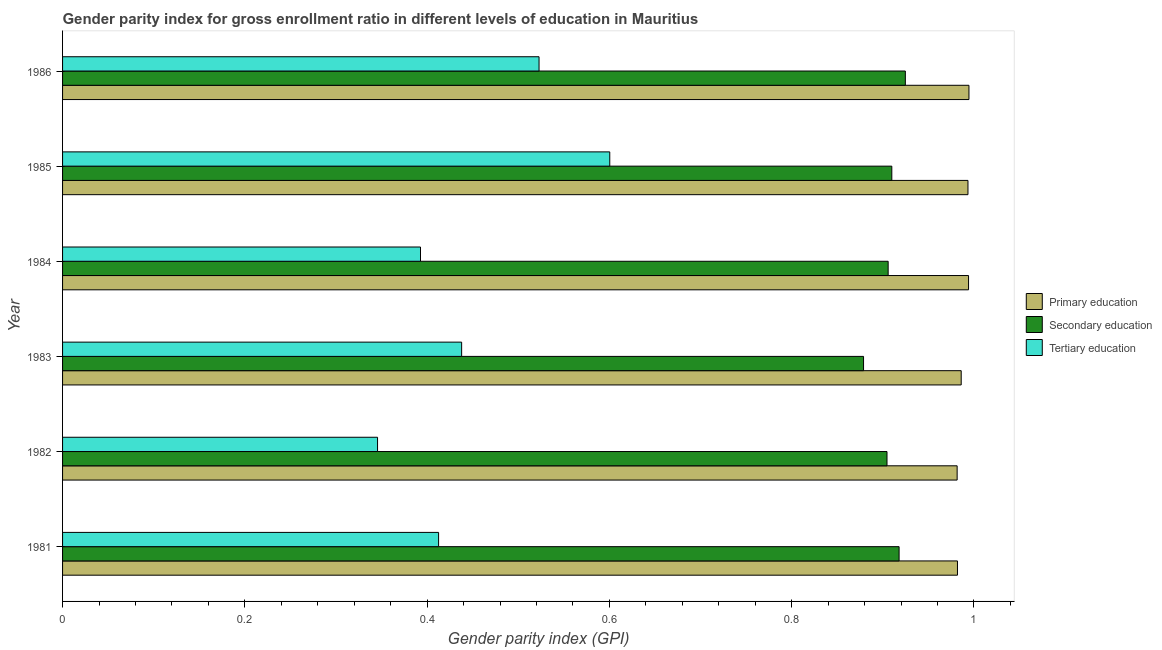How many different coloured bars are there?
Offer a very short reply. 3. How many groups of bars are there?
Offer a very short reply. 6. Are the number of bars on each tick of the Y-axis equal?
Give a very brief answer. Yes. What is the label of the 3rd group of bars from the top?
Your answer should be very brief. 1984. What is the gender parity index in primary education in 1985?
Ensure brevity in your answer.  0.99. Across all years, what is the maximum gender parity index in tertiary education?
Your answer should be very brief. 0.6. Across all years, what is the minimum gender parity index in tertiary education?
Your answer should be compact. 0.35. In which year was the gender parity index in secondary education maximum?
Give a very brief answer. 1986. In which year was the gender parity index in secondary education minimum?
Provide a short and direct response. 1983. What is the total gender parity index in tertiary education in the graph?
Provide a succinct answer. 2.71. What is the difference between the gender parity index in primary education in 1982 and that in 1984?
Make the answer very short. -0.01. What is the difference between the gender parity index in primary education in 1981 and the gender parity index in secondary education in 1982?
Keep it short and to the point. 0.08. In the year 1984, what is the difference between the gender parity index in primary education and gender parity index in tertiary education?
Your response must be concise. 0.6. In how many years, is the gender parity index in tertiary education greater than 0.6000000000000001 ?
Ensure brevity in your answer.  1. What is the ratio of the gender parity index in tertiary education in 1982 to that in 1985?
Make the answer very short. 0.58. Is the gender parity index in primary education in 1983 less than that in 1984?
Your response must be concise. Yes. What is the difference between the highest and the second highest gender parity index in secondary education?
Provide a succinct answer. 0.01. In how many years, is the gender parity index in secondary education greater than the average gender parity index in secondary education taken over all years?
Provide a short and direct response. 3. Is the sum of the gender parity index in primary education in 1981 and 1986 greater than the maximum gender parity index in tertiary education across all years?
Provide a short and direct response. Yes. What does the 1st bar from the top in 1985 represents?
Your answer should be compact. Tertiary education. Is it the case that in every year, the sum of the gender parity index in primary education and gender parity index in secondary education is greater than the gender parity index in tertiary education?
Provide a succinct answer. Yes. Does the graph contain grids?
Offer a very short reply. No. Where does the legend appear in the graph?
Your answer should be compact. Center right. What is the title of the graph?
Offer a very short reply. Gender parity index for gross enrollment ratio in different levels of education in Mauritius. Does "Transport services" appear as one of the legend labels in the graph?
Your answer should be compact. No. What is the label or title of the X-axis?
Keep it short and to the point. Gender parity index (GPI). What is the label or title of the Y-axis?
Provide a short and direct response. Year. What is the Gender parity index (GPI) in Primary education in 1981?
Keep it short and to the point. 0.98. What is the Gender parity index (GPI) of Secondary education in 1981?
Offer a terse response. 0.92. What is the Gender parity index (GPI) of Tertiary education in 1981?
Give a very brief answer. 0.41. What is the Gender parity index (GPI) of Primary education in 1982?
Make the answer very short. 0.98. What is the Gender parity index (GPI) in Secondary education in 1982?
Ensure brevity in your answer.  0.9. What is the Gender parity index (GPI) of Tertiary education in 1982?
Offer a very short reply. 0.35. What is the Gender parity index (GPI) in Primary education in 1983?
Your answer should be very brief. 0.99. What is the Gender parity index (GPI) of Secondary education in 1983?
Your answer should be very brief. 0.88. What is the Gender parity index (GPI) in Tertiary education in 1983?
Provide a succinct answer. 0.44. What is the Gender parity index (GPI) of Primary education in 1984?
Offer a very short reply. 0.99. What is the Gender parity index (GPI) of Secondary education in 1984?
Give a very brief answer. 0.91. What is the Gender parity index (GPI) in Tertiary education in 1984?
Keep it short and to the point. 0.39. What is the Gender parity index (GPI) of Primary education in 1985?
Give a very brief answer. 0.99. What is the Gender parity index (GPI) of Secondary education in 1985?
Provide a short and direct response. 0.91. What is the Gender parity index (GPI) of Tertiary education in 1985?
Offer a very short reply. 0.6. What is the Gender parity index (GPI) in Primary education in 1986?
Your answer should be very brief. 0.99. What is the Gender parity index (GPI) in Secondary education in 1986?
Make the answer very short. 0.92. What is the Gender parity index (GPI) of Tertiary education in 1986?
Your answer should be very brief. 0.52. Across all years, what is the maximum Gender parity index (GPI) of Primary education?
Your response must be concise. 0.99. Across all years, what is the maximum Gender parity index (GPI) of Secondary education?
Ensure brevity in your answer.  0.92. Across all years, what is the maximum Gender parity index (GPI) in Tertiary education?
Give a very brief answer. 0.6. Across all years, what is the minimum Gender parity index (GPI) of Primary education?
Offer a very short reply. 0.98. Across all years, what is the minimum Gender parity index (GPI) in Secondary education?
Provide a short and direct response. 0.88. Across all years, what is the minimum Gender parity index (GPI) in Tertiary education?
Keep it short and to the point. 0.35. What is the total Gender parity index (GPI) in Primary education in the graph?
Provide a short and direct response. 5.93. What is the total Gender parity index (GPI) in Secondary education in the graph?
Your answer should be compact. 5.44. What is the total Gender parity index (GPI) in Tertiary education in the graph?
Give a very brief answer. 2.71. What is the difference between the Gender parity index (GPI) in Primary education in 1981 and that in 1982?
Make the answer very short. 0. What is the difference between the Gender parity index (GPI) in Secondary education in 1981 and that in 1982?
Ensure brevity in your answer.  0.01. What is the difference between the Gender parity index (GPI) of Tertiary education in 1981 and that in 1982?
Offer a very short reply. 0.07. What is the difference between the Gender parity index (GPI) in Primary education in 1981 and that in 1983?
Your response must be concise. -0. What is the difference between the Gender parity index (GPI) of Secondary education in 1981 and that in 1983?
Provide a succinct answer. 0.04. What is the difference between the Gender parity index (GPI) in Tertiary education in 1981 and that in 1983?
Give a very brief answer. -0.03. What is the difference between the Gender parity index (GPI) in Primary education in 1981 and that in 1984?
Your answer should be compact. -0.01. What is the difference between the Gender parity index (GPI) of Secondary education in 1981 and that in 1984?
Your answer should be very brief. 0.01. What is the difference between the Gender parity index (GPI) in Tertiary education in 1981 and that in 1984?
Offer a very short reply. 0.02. What is the difference between the Gender parity index (GPI) of Primary education in 1981 and that in 1985?
Provide a short and direct response. -0.01. What is the difference between the Gender parity index (GPI) of Secondary education in 1981 and that in 1985?
Offer a terse response. 0.01. What is the difference between the Gender parity index (GPI) of Tertiary education in 1981 and that in 1985?
Provide a succinct answer. -0.19. What is the difference between the Gender parity index (GPI) in Primary education in 1981 and that in 1986?
Offer a very short reply. -0.01. What is the difference between the Gender parity index (GPI) of Secondary education in 1981 and that in 1986?
Your answer should be very brief. -0.01. What is the difference between the Gender parity index (GPI) in Tertiary education in 1981 and that in 1986?
Ensure brevity in your answer.  -0.11. What is the difference between the Gender parity index (GPI) of Primary education in 1982 and that in 1983?
Your answer should be very brief. -0. What is the difference between the Gender parity index (GPI) of Secondary education in 1982 and that in 1983?
Keep it short and to the point. 0.03. What is the difference between the Gender parity index (GPI) of Tertiary education in 1982 and that in 1983?
Your response must be concise. -0.09. What is the difference between the Gender parity index (GPI) of Primary education in 1982 and that in 1984?
Provide a succinct answer. -0.01. What is the difference between the Gender parity index (GPI) of Secondary education in 1982 and that in 1984?
Offer a terse response. -0. What is the difference between the Gender parity index (GPI) in Tertiary education in 1982 and that in 1984?
Your response must be concise. -0.05. What is the difference between the Gender parity index (GPI) of Primary education in 1982 and that in 1985?
Make the answer very short. -0.01. What is the difference between the Gender parity index (GPI) of Secondary education in 1982 and that in 1985?
Offer a terse response. -0.01. What is the difference between the Gender parity index (GPI) in Tertiary education in 1982 and that in 1985?
Your answer should be very brief. -0.25. What is the difference between the Gender parity index (GPI) in Primary education in 1982 and that in 1986?
Offer a terse response. -0.01. What is the difference between the Gender parity index (GPI) in Secondary education in 1982 and that in 1986?
Keep it short and to the point. -0.02. What is the difference between the Gender parity index (GPI) of Tertiary education in 1982 and that in 1986?
Provide a short and direct response. -0.18. What is the difference between the Gender parity index (GPI) in Primary education in 1983 and that in 1984?
Provide a short and direct response. -0.01. What is the difference between the Gender parity index (GPI) of Secondary education in 1983 and that in 1984?
Ensure brevity in your answer.  -0.03. What is the difference between the Gender parity index (GPI) of Tertiary education in 1983 and that in 1984?
Ensure brevity in your answer.  0.05. What is the difference between the Gender parity index (GPI) of Primary education in 1983 and that in 1985?
Give a very brief answer. -0.01. What is the difference between the Gender parity index (GPI) in Secondary education in 1983 and that in 1985?
Offer a very short reply. -0.03. What is the difference between the Gender parity index (GPI) in Tertiary education in 1983 and that in 1985?
Your answer should be compact. -0.16. What is the difference between the Gender parity index (GPI) of Primary education in 1983 and that in 1986?
Ensure brevity in your answer.  -0.01. What is the difference between the Gender parity index (GPI) of Secondary education in 1983 and that in 1986?
Provide a succinct answer. -0.05. What is the difference between the Gender parity index (GPI) of Tertiary education in 1983 and that in 1986?
Offer a very short reply. -0.08. What is the difference between the Gender parity index (GPI) in Primary education in 1984 and that in 1985?
Offer a terse response. 0. What is the difference between the Gender parity index (GPI) of Secondary education in 1984 and that in 1985?
Make the answer very short. -0. What is the difference between the Gender parity index (GPI) in Tertiary education in 1984 and that in 1985?
Offer a terse response. -0.21. What is the difference between the Gender parity index (GPI) of Primary education in 1984 and that in 1986?
Your answer should be very brief. -0. What is the difference between the Gender parity index (GPI) in Secondary education in 1984 and that in 1986?
Offer a terse response. -0.02. What is the difference between the Gender parity index (GPI) in Tertiary education in 1984 and that in 1986?
Your answer should be very brief. -0.13. What is the difference between the Gender parity index (GPI) of Primary education in 1985 and that in 1986?
Your answer should be very brief. -0. What is the difference between the Gender parity index (GPI) of Secondary education in 1985 and that in 1986?
Give a very brief answer. -0.01. What is the difference between the Gender parity index (GPI) in Tertiary education in 1985 and that in 1986?
Provide a succinct answer. 0.08. What is the difference between the Gender parity index (GPI) of Primary education in 1981 and the Gender parity index (GPI) of Secondary education in 1982?
Offer a very short reply. 0.08. What is the difference between the Gender parity index (GPI) of Primary education in 1981 and the Gender parity index (GPI) of Tertiary education in 1982?
Ensure brevity in your answer.  0.64. What is the difference between the Gender parity index (GPI) in Secondary education in 1981 and the Gender parity index (GPI) in Tertiary education in 1982?
Offer a very short reply. 0.57. What is the difference between the Gender parity index (GPI) in Primary education in 1981 and the Gender parity index (GPI) in Secondary education in 1983?
Your answer should be very brief. 0.1. What is the difference between the Gender parity index (GPI) in Primary education in 1981 and the Gender parity index (GPI) in Tertiary education in 1983?
Provide a succinct answer. 0.54. What is the difference between the Gender parity index (GPI) of Secondary education in 1981 and the Gender parity index (GPI) of Tertiary education in 1983?
Keep it short and to the point. 0.48. What is the difference between the Gender parity index (GPI) of Primary education in 1981 and the Gender parity index (GPI) of Secondary education in 1984?
Your answer should be very brief. 0.08. What is the difference between the Gender parity index (GPI) in Primary education in 1981 and the Gender parity index (GPI) in Tertiary education in 1984?
Offer a very short reply. 0.59. What is the difference between the Gender parity index (GPI) of Secondary education in 1981 and the Gender parity index (GPI) of Tertiary education in 1984?
Your answer should be very brief. 0.53. What is the difference between the Gender parity index (GPI) of Primary education in 1981 and the Gender parity index (GPI) of Secondary education in 1985?
Give a very brief answer. 0.07. What is the difference between the Gender parity index (GPI) in Primary education in 1981 and the Gender parity index (GPI) in Tertiary education in 1985?
Keep it short and to the point. 0.38. What is the difference between the Gender parity index (GPI) of Secondary education in 1981 and the Gender parity index (GPI) of Tertiary education in 1985?
Your answer should be very brief. 0.32. What is the difference between the Gender parity index (GPI) of Primary education in 1981 and the Gender parity index (GPI) of Secondary education in 1986?
Provide a succinct answer. 0.06. What is the difference between the Gender parity index (GPI) of Primary education in 1981 and the Gender parity index (GPI) of Tertiary education in 1986?
Your answer should be very brief. 0.46. What is the difference between the Gender parity index (GPI) in Secondary education in 1981 and the Gender parity index (GPI) in Tertiary education in 1986?
Provide a short and direct response. 0.4. What is the difference between the Gender parity index (GPI) in Primary education in 1982 and the Gender parity index (GPI) in Secondary education in 1983?
Offer a terse response. 0.1. What is the difference between the Gender parity index (GPI) of Primary education in 1982 and the Gender parity index (GPI) of Tertiary education in 1983?
Give a very brief answer. 0.54. What is the difference between the Gender parity index (GPI) in Secondary education in 1982 and the Gender parity index (GPI) in Tertiary education in 1983?
Ensure brevity in your answer.  0.47. What is the difference between the Gender parity index (GPI) of Primary education in 1982 and the Gender parity index (GPI) of Secondary education in 1984?
Provide a short and direct response. 0.08. What is the difference between the Gender parity index (GPI) of Primary education in 1982 and the Gender parity index (GPI) of Tertiary education in 1984?
Give a very brief answer. 0.59. What is the difference between the Gender parity index (GPI) of Secondary education in 1982 and the Gender parity index (GPI) of Tertiary education in 1984?
Provide a short and direct response. 0.51. What is the difference between the Gender parity index (GPI) of Primary education in 1982 and the Gender parity index (GPI) of Secondary education in 1985?
Your answer should be compact. 0.07. What is the difference between the Gender parity index (GPI) in Primary education in 1982 and the Gender parity index (GPI) in Tertiary education in 1985?
Your answer should be compact. 0.38. What is the difference between the Gender parity index (GPI) in Secondary education in 1982 and the Gender parity index (GPI) in Tertiary education in 1985?
Your response must be concise. 0.3. What is the difference between the Gender parity index (GPI) in Primary education in 1982 and the Gender parity index (GPI) in Secondary education in 1986?
Offer a very short reply. 0.06. What is the difference between the Gender parity index (GPI) of Primary education in 1982 and the Gender parity index (GPI) of Tertiary education in 1986?
Give a very brief answer. 0.46. What is the difference between the Gender parity index (GPI) in Secondary education in 1982 and the Gender parity index (GPI) in Tertiary education in 1986?
Your answer should be very brief. 0.38. What is the difference between the Gender parity index (GPI) of Primary education in 1983 and the Gender parity index (GPI) of Secondary education in 1984?
Provide a succinct answer. 0.08. What is the difference between the Gender parity index (GPI) in Primary education in 1983 and the Gender parity index (GPI) in Tertiary education in 1984?
Your answer should be compact. 0.59. What is the difference between the Gender parity index (GPI) of Secondary education in 1983 and the Gender parity index (GPI) of Tertiary education in 1984?
Your answer should be very brief. 0.49. What is the difference between the Gender parity index (GPI) in Primary education in 1983 and the Gender parity index (GPI) in Secondary education in 1985?
Give a very brief answer. 0.08. What is the difference between the Gender parity index (GPI) in Primary education in 1983 and the Gender parity index (GPI) in Tertiary education in 1985?
Your answer should be very brief. 0.39. What is the difference between the Gender parity index (GPI) of Secondary education in 1983 and the Gender parity index (GPI) of Tertiary education in 1985?
Provide a succinct answer. 0.28. What is the difference between the Gender parity index (GPI) of Primary education in 1983 and the Gender parity index (GPI) of Secondary education in 1986?
Provide a short and direct response. 0.06. What is the difference between the Gender parity index (GPI) in Primary education in 1983 and the Gender parity index (GPI) in Tertiary education in 1986?
Provide a succinct answer. 0.46. What is the difference between the Gender parity index (GPI) in Secondary education in 1983 and the Gender parity index (GPI) in Tertiary education in 1986?
Your answer should be compact. 0.36. What is the difference between the Gender parity index (GPI) of Primary education in 1984 and the Gender parity index (GPI) of Secondary education in 1985?
Keep it short and to the point. 0.08. What is the difference between the Gender parity index (GPI) of Primary education in 1984 and the Gender parity index (GPI) of Tertiary education in 1985?
Give a very brief answer. 0.39. What is the difference between the Gender parity index (GPI) of Secondary education in 1984 and the Gender parity index (GPI) of Tertiary education in 1985?
Offer a terse response. 0.31. What is the difference between the Gender parity index (GPI) of Primary education in 1984 and the Gender parity index (GPI) of Secondary education in 1986?
Your answer should be compact. 0.07. What is the difference between the Gender parity index (GPI) of Primary education in 1984 and the Gender parity index (GPI) of Tertiary education in 1986?
Your answer should be very brief. 0.47. What is the difference between the Gender parity index (GPI) of Secondary education in 1984 and the Gender parity index (GPI) of Tertiary education in 1986?
Give a very brief answer. 0.38. What is the difference between the Gender parity index (GPI) of Primary education in 1985 and the Gender parity index (GPI) of Secondary education in 1986?
Give a very brief answer. 0.07. What is the difference between the Gender parity index (GPI) in Primary education in 1985 and the Gender parity index (GPI) in Tertiary education in 1986?
Keep it short and to the point. 0.47. What is the difference between the Gender parity index (GPI) in Secondary education in 1985 and the Gender parity index (GPI) in Tertiary education in 1986?
Give a very brief answer. 0.39. What is the average Gender parity index (GPI) of Secondary education per year?
Keep it short and to the point. 0.91. What is the average Gender parity index (GPI) in Tertiary education per year?
Make the answer very short. 0.45. In the year 1981, what is the difference between the Gender parity index (GPI) in Primary education and Gender parity index (GPI) in Secondary education?
Your answer should be very brief. 0.06. In the year 1981, what is the difference between the Gender parity index (GPI) of Primary education and Gender parity index (GPI) of Tertiary education?
Your answer should be very brief. 0.57. In the year 1981, what is the difference between the Gender parity index (GPI) in Secondary education and Gender parity index (GPI) in Tertiary education?
Provide a short and direct response. 0.51. In the year 1982, what is the difference between the Gender parity index (GPI) in Primary education and Gender parity index (GPI) in Secondary education?
Your response must be concise. 0.08. In the year 1982, what is the difference between the Gender parity index (GPI) of Primary education and Gender parity index (GPI) of Tertiary education?
Provide a succinct answer. 0.64. In the year 1982, what is the difference between the Gender parity index (GPI) of Secondary education and Gender parity index (GPI) of Tertiary education?
Keep it short and to the point. 0.56. In the year 1983, what is the difference between the Gender parity index (GPI) in Primary education and Gender parity index (GPI) in Secondary education?
Offer a very short reply. 0.11. In the year 1983, what is the difference between the Gender parity index (GPI) of Primary education and Gender parity index (GPI) of Tertiary education?
Make the answer very short. 0.55. In the year 1983, what is the difference between the Gender parity index (GPI) in Secondary education and Gender parity index (GPI) in Tertiary education?
Offer a very short reply. 0.44. In the year 1984, what is the difference between the Gender parity index (GPI) in Primary education and Gender parity index (GPI) in Secondary education?
Ensure brevity in your answer.  0.09. In the year 1984, what is the difference between the Gender parity index (GPI) in Primary education and Gender parity index (GPI) in Tertiary education?
Offer a terse response. 0.6. In the year 1984, what is the difference between the Gender parity index (GPI) of Secondary education and Gender parity index (GPI) of Tertiary education?
Your response must be concise. 0.51. In the year 1985, what is the difference between the Gender parity index (GPI) in Primary education and Gender parity index (GPI) in Secondary education?
Provide a short and direct response. 0.08. In the year 1985, what is the difference between the Gender parity index (GPI) of Primary education and Gender parity index (GPI) of Tertiary education?
Provide a short and direct response. 0.39. In the year 1985, what is the difference between the Gender parity index (GPI) of Secondary education and Gender parity index (GPI) of Tertiary education?
Ensure brevity in your answer.  0.31. In the year 1986, what is the difference between the Gender parity index (GPI) in Primary education and Gender parity index (GPI) in Secondary education?
Offer a very short reply. 0.07. In the year 1986, what is the difference between the Gender parity index (GPI) in Primary education and Gender parity index (GPI) in Tertiary education?
Your answer should be very brief. 0.47. In the year 1986, what is the difference between the Gender parity index (GPI) of Secondary education and Gender parity index (GPI) of Tertiary education?
Give a very brief answer. 0.4. What is the ratio of the Gender parity index (GPI) of Secondary education in 1981 to that in 1982?
Your answer should be compact. 1.01. What is the ratio of the Gender parity index (GPI) of Tertiary education in 1981 to that in 1982?
Provide a succinct answer. 1.19. What is the ratio of the Gender parity index (GPI) in Primary education in 1981 to that in 1983?
Provide a short and direct response. 1. What is the ratio of the Gender parity index (GPI) in Secondary education in 1981 to that in 1983?
Give a very brief answer. 1.04. What is the ratio of the Gender parity index (GPI) in Tertiary education in 1981 to that in 1983?
Your answer should be compact. 0.94. What is the ratio of the Gender parity index (GPI) in Primary education in 1981 to that in 1984?
Provide a succinct answer. 0.99. What is the ratio of the Gender parity index (GPI) of Secondary education in 1981 to that in 1984?
Keep it short and to the point. 1.01. What is the ratio of the Gender parity index (GPI) in Tertiary education in 1981 to that in 1984?
Offer a very short reply. 1.05. What is the ratio of the Gender parity index (GPI) in Primary education in 1981 to that in 1985?
Your answer should be compact. 0.99. What is the ratio of the Gender parity index (GPI) in Secondary education in 1981 to that in 1985?
Make the answer very short. 1.01. What is the ratio of the Gender parity index (GPI) in Tertiary education in 1981 to that in 1985?
Provide a short and direct response. 0.69. What is the ratio of the Gender parity index (GPI) of Primary education in 1981 to that in 1986?
Provide a short and direct response. 0.99. What is the ratio of the Gender parity index (GPI) in Secondary education in 1981 to that in 1986?
Your answer should be very brief. 0.99. What is the ratio of the Gender parity index (GPI) in Tertiary education in 1981 to that in 1986?
Give a very brief answer. 0.79. What is the ratio of the Gender parity index (GPI) in Primary education in 1982 to that in 1983?
Offer a very short reply. 1. What is the ratio of the Gender parity index (GPI) of Secondary education in 1982 to that in 1983?
Your answer should be compact. 1.03. What is the ratio of the Gender parity index (GPI) of Tertiary education in 1982 to that in 1983?
Provide a short and direct response. 0.79. What is the ratio of the Gender parity index (GPI) in Primary education in 1982 to that in 1984?
Provide a succinct answer. 0.99. What is the ratio of the Gender parity index (GPI) in Secondary education in 1982 to that in 1985?
Provide a short and direct response. 0.99. What is the ratio of the Gender parity index (GPI) of Tertiary education in 1982 to that in 1985?
Your answer should be very brief. 0.58. What is the ratio of the Gender parity index (GPI) in Primary education in 1982 to that in 1986?
Offer a terse response. 0.99. What is the ratio of the Gender parity index (GPI) of Secondary education in 1982 to that in 1986?
Offer a terse response. 0.98. What is the ratio of the Gender parity index (GPI) of Tertiary education in 1982 to that in 1986?
Make the answer very short. 0.66. What is the ratio of the Gender parity index (GPI) in Primary education in 1983 to that in 1984?
Give a very brief answer. 0.99. What is the ratio of the Gender parity index (GPI) of Secondary education in 1983 to that in 1984?
Offer a terse response. 0.97. What is the ratio of the Gender parity index (GPI) in Tertiary education in 1983 to that in 1984?
Ensure brevity in your answer.  1.11. What is the ratio of the Gender parity index (GPI) of Primary education in 1983 to that in 1985?
Your response must be concise. 0.99. What is the ratio of the Gender parity index (GPI) of Secondary education in 1983 to that in 1985?
Your response must be concise. 0.97. What is the ratio of the Gender parity index (GPI) in Tertiary education in 1983 to that in 1985?
Offer a terse response. 0.73. What is the ratio of the Gender parity index (GPI) in Secondary education in 1983 to that in 1986?
Give a very brief answer. 0.95. What is the ratio of the Gender parity index (GPI) in Tertiary education in 1983 to that in 1986?
Your response must be concise. 0.84. What is the ratio of the Gender parity index (GPI) of Tertiary education in 1984 to that in 1985?
Your answer should be very brief. 0.65. What is the ratio of the Gender parity index (GPI) of Secondary education in 1984 to that in 1986?
Your answer should be very brief. 0.98. What is the ratio of the Gender parity index (GPI) in Tertiary education in 1984 to that in 1986?
Your answer should be very brief. 0.75. What is the ratio of the Gender parity index (GPI) of Secondary education in 1985 to that in 1986?
Provide a short and direct response. 0.98. What is the ratio of the Gender parity index (GPI) in Tertiary education in 1985 to that in 1986?
Provide a succinct answer. 1.15. What is the difference between the highest and the second highest Gender parity index (GPI) in Primary education?
Offer a very short reply. 0. What is the difference between the highest and the second highest Gender parity index (GPI) of Secondary education?
Provide a succinct answer. 0.01. What is the difference between the highest and the second highest Gender parity index (GPI) in Tertiary education?
Give a very brief answer. 0.08. What is the difference between the highest and the lowest Gender parity index (GPI) in Primary education?
Ensure brevity in your answer.  0.01. What is the difference between the highest and the lowest Gender parity index (GPI) in Secondary education?
Keep it short and to the point. 0.05. What is the difference between the highest and the lowest Gender parity index (GPI) of Tertiary education?
Your response must be concise. 0.25. 